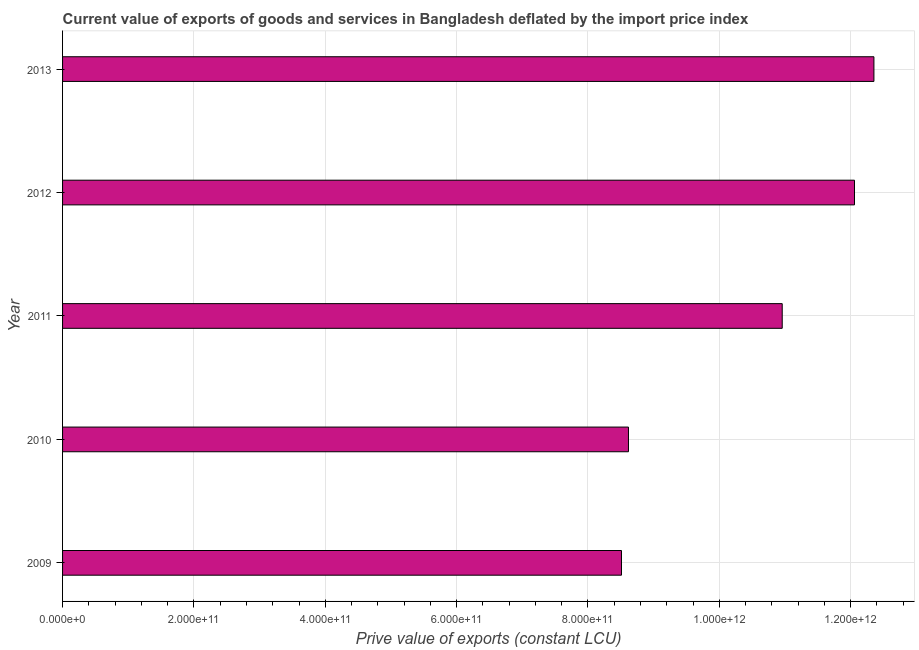What is the title of the graph?
Keep it short and to the point. Current value of exports of goods and services in Bangladesh deflated by the import price index. What is the label or title of the X-axis?
Offer a terse response. Prive value of exports (constant LCU). What is the price value of exports in 2009?
Provide a succinct answer. 8.51e+11. Across all years, what is the maximum price value of exports?
Offer a terse response. 1.24e+12. Across all years, what is the minimum price value of exports?
Offer a terse response. 8.51e+11. What is the sum of the price value of exports?
Give a very brief answer. 5.25e+12. What is the difference between the price value of exports in 2009 and 2013?
Your response must be concise. -3.84e+11. What is the average price value of exports per year?
Ensure brevity in your answer.  1.05e+12. What is the median price value of exports?
Ensure brevity in your answer.  1.10e+12. What is the ratio of the price value of exports in 2010 to that in 2011?
Make the answer very short. 0.79. Is the difference between the price value of exports in 2009 and 2011 greater than the difference between any two years?
Provide a succinct answer. No. What is the difference between the highest and the second highest price value of exports?
Your answer should be compact. 2.96e+1. Is the sum of the price value of exports in 2009 and 2013 greater than the maximum price value of exports across all years?
Make the answer very short. Yes. What is the difference between the highest and the lowest price value of exports?
Provide a short and direct response. 3.84e+11. In how many years, is the price value of exports greater than the average price value of exports taken over all years?
Ensure brevity in your answer.  3. What is the difference between two consecutive major ticks on the X-axis?
Your answer should be very brief. 2.00e+11. Are the values on the major ticks of X-axis written in scientific E-notation?
Your answer should be compact. Yes. What is the Prive value of exports (constant LCU) of 2009?
Keep it short and to the point. 8.51e+11. What is the Prive value of exports (constant LCU) in 2010?
Offer a terse response. 8.62e+11. What is the Prive value of exports (constant LCU) in 2011?
Keep it short and to the point. 1.10e+12. What is the Prive value of exports (constant LCU) in 2012?
Ensure brevity in your answer.  1.21e+12. What is the Prive value of exports (constant LCU) of 2013?
Your answer should be compact. 1.24e+12. What is the difference between the Prive value of exports (constant LCU) in 2009 and 2010?
Make the answer very short. -1.06e+1. What is the difference between the Prive value of exports (constant LCU) in 2009 and 2011?
Your response must be concise. -2.45e+11. What is the difference between the Prive value of exports (constant LCU) in 2009 and 2012?
Your answer should be compact. -3.55e+11. What is the difference between the Prive value of exports (constant LCU) in 2009 and 2013?
Give a very brief answer. -3.84e+11. What is the difference between the Prive value of exports (constant LCU) in 2010 and 2011?
Offer a very short reply. -2.34e+11. What is the difference between the Prive value of exports (constant LCU) in 2010 and 2012?
Make the answer very short. -3.44e+11. What is the difference between the Prive value of exports (constant LCU) in 2010 and 2013?
Your response must be concise. -3.74e+11. What is the difference between the Prive value of exports (constant LCU) in 2011 and 2012?
Make the answer very short. -1.10e+11. What is the difference between the Prive value of exports (constant LCU) in 2011 and 2013?
Your answer should be compact. -1.40e+11. What is the difference between the Prive value of exports (constant LCU) in 2012 and 2013?
Your answer should be very brief. -2.96e+1. What is the ratio of the Prive value of exports (constant LCU) in 2009 to that in 2011?
Your answer should be compact. 0.78. What is the ratio of the Prive value of exports (constant LCU) in 2009 to that in 2012?
Your answer should be compact. 0.71. What is the ratio of the Prive value of exports (constant LCU) in 2009 to that in 2013?
Offer a terse response. 0.69. What is the ratio of the Prive value of exports (constant LCU) in 2010 to that in 2011?
Offer a terse response. 0.79. What is the ratio of the Prive value of exports (constant LCU) in 2010 to that in 2012?
Keep it short and to the point. 0.71. What is the ratio of the Prive value of exports (constant LCU) in 2010 to that in 2013?
Your answer should be very brief. 0.7. What is the ratio of the Prive value of exports (constant LCU) in 2011 to that in 2012?
Your answer should be very brief. 0.91. What is the ratio of the Prive value of exports (constant LCU) in 2011 to that in 2013?
Your answer should be very brief. 0.89. 